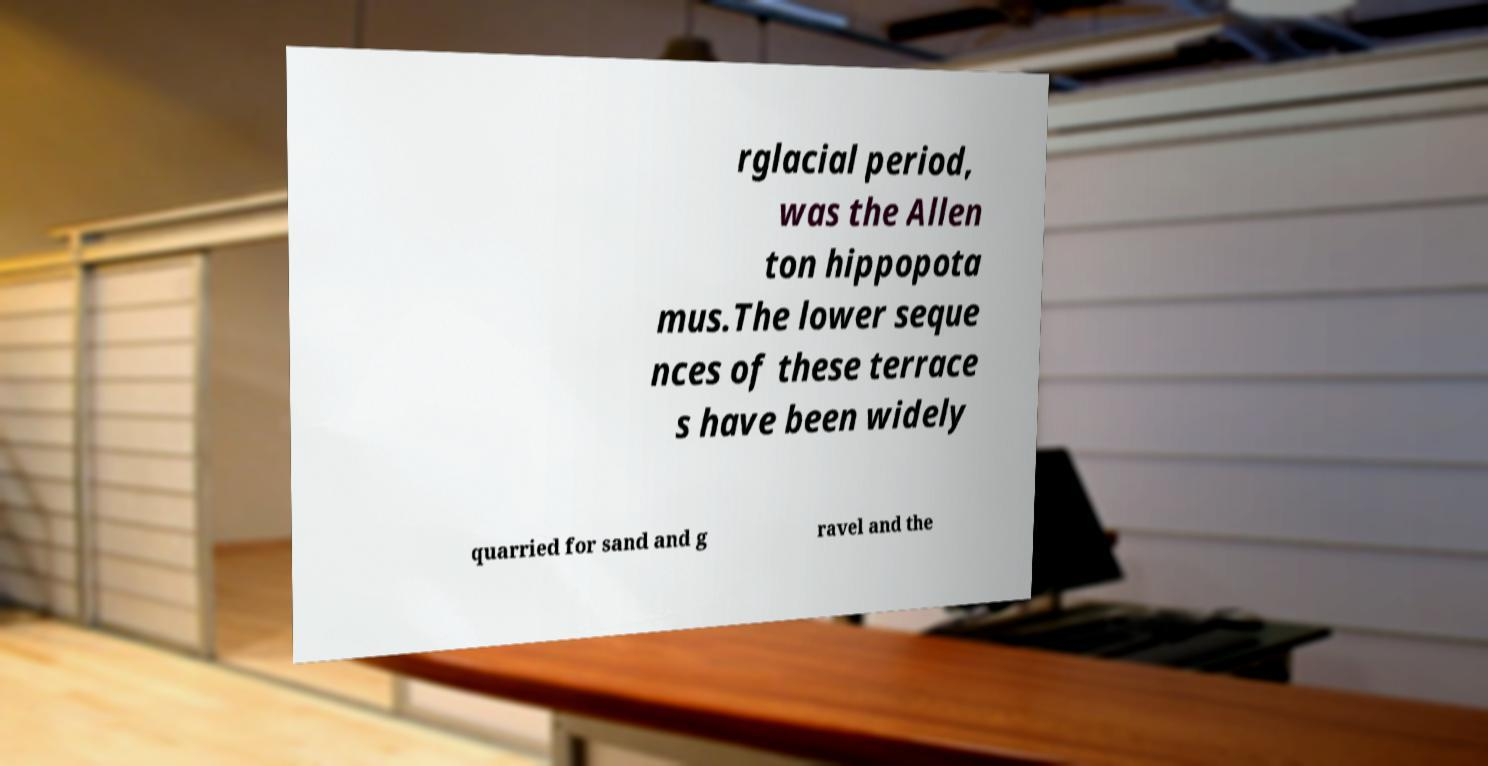What messages or text are displayed in this image? I need them in a readable, typed format. rglacial period, was the Allen ton hippopota mus.The lower seque nces of these terrace s have been widely quarried for sand and g ravel and the 